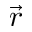Convert formula to latex. <formula><loc_0><loc_0><loc_500><loc_500>\vec { r }</formula> 